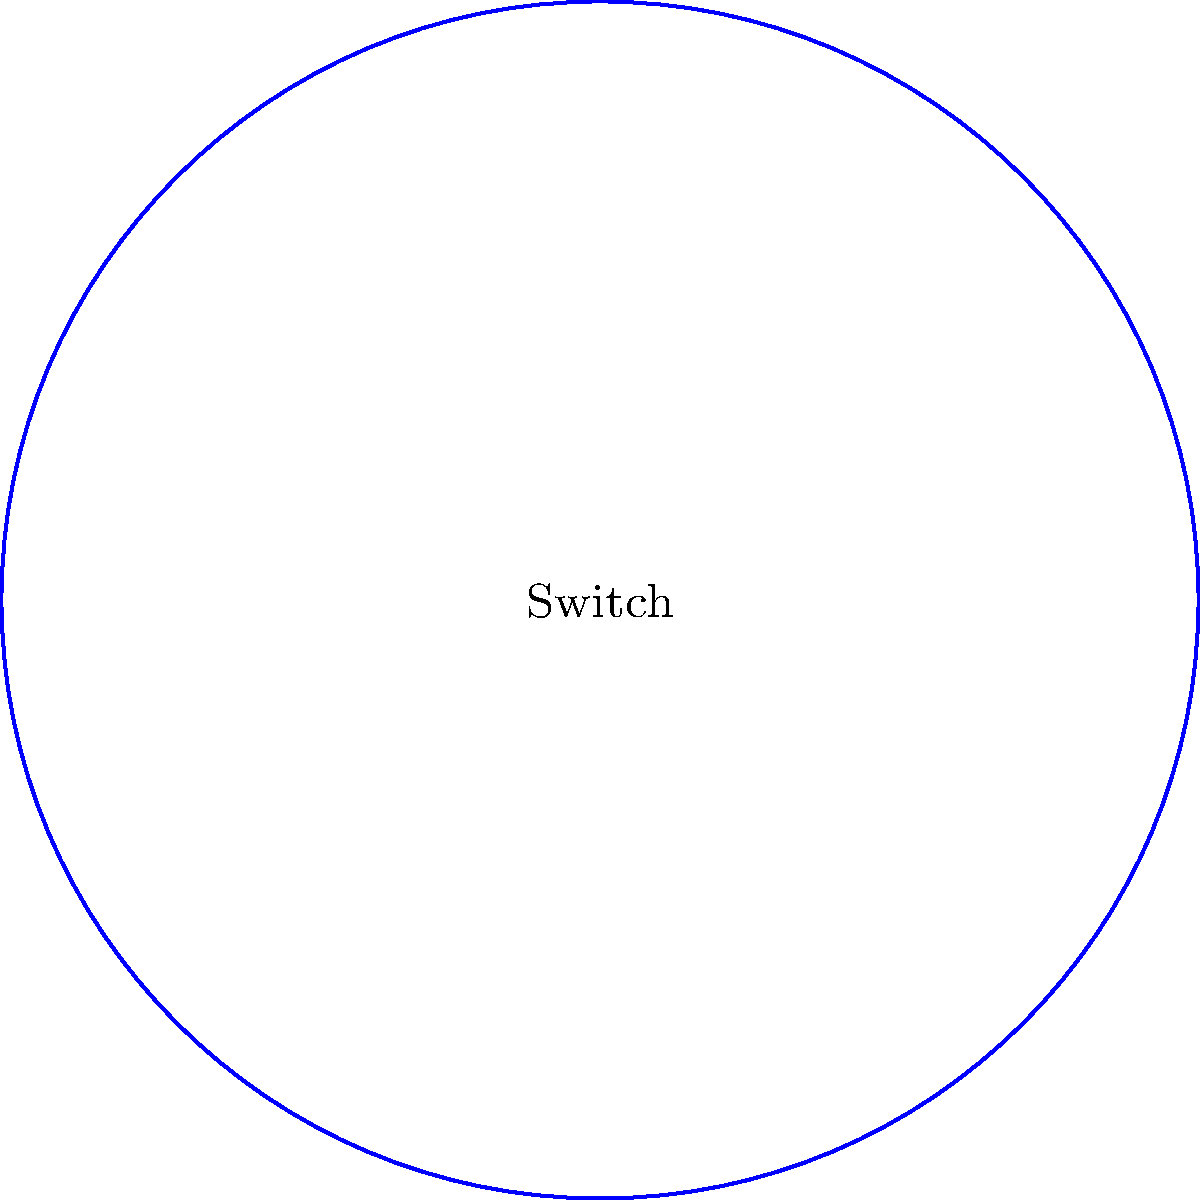In the star topology network shown above, the central switch has a 1 Gbps connection to Node 1, while all other nodes are connected at 100 Mbps. If Node 1 is sending data to all other nodes simultaneously, what is the maximum theoretical throughput for any single receiving node, and what causes this limitation? To determine the bottleneck in this star topology network, we need to analyze the connection speeds and the network's structure:

1. The central switch has a 1 Gbps (1000 Mbps) connection to Node 1.
2. All other nodes (2-8) have 100 Mbps connections to the central switch.
3. Node 1 is sending data to all other nodes simultaneously.

Step-by-step analysis:
1. Node 1 can send data at a maximum rate of 1 Gbps to the switch.
2. The switch can receive this data at 1 Gbps, so there's no bottleneck at the input.
3. However, when the switch forwards the data to the other nodes, it's limited by their connection speeds.
4. Each receiving node is connected at 100 Mbps, which is slower than the input rate from Node 1.
5. The switch must buffer and transmit data to each node at their maximum speed of 100 Mbps.
6. Even if Node 1 is sending at full 1 Gbps capacity, no single receiving node can receive faster than its own connection speed.

Therefore, the maximum theoretical throughput for any single receiving node is limited to 100 Mbps, regardless of the faster input from Node 1. This limitation is caused by the slower 100 Mbps connections between the switch and the receiving nodes, creating a bottleneck in the network.
Answer: 100 Mbps; limited by receiving nodes' connection speed 